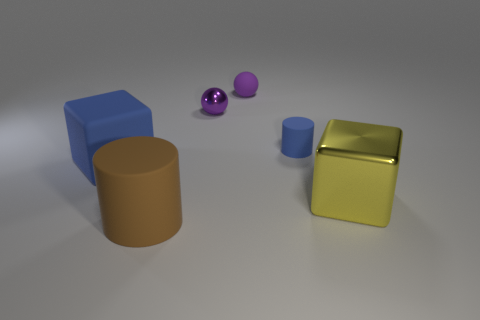Add 3 big yellow metal blocks. How many objects exist? 9 Subtract all blocks. How many objects are left? 4 Subtract all gray cubes. Subtract all big blue objects. How many objects are left? 5 Add 4 big matte objects. How many big matte objects are left? 6 Add 6 big brown rubber cylinders. How many big brown rubber cylinders exist? 7 Subtract 0 cyan cubes. How many objects are left? 6 